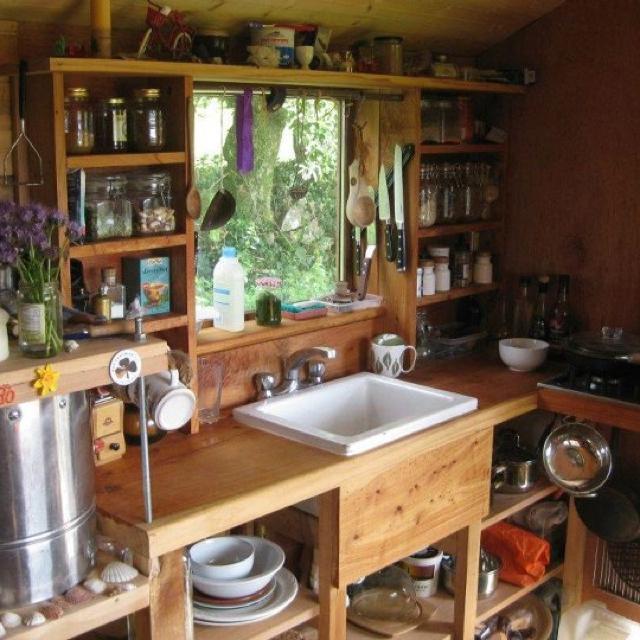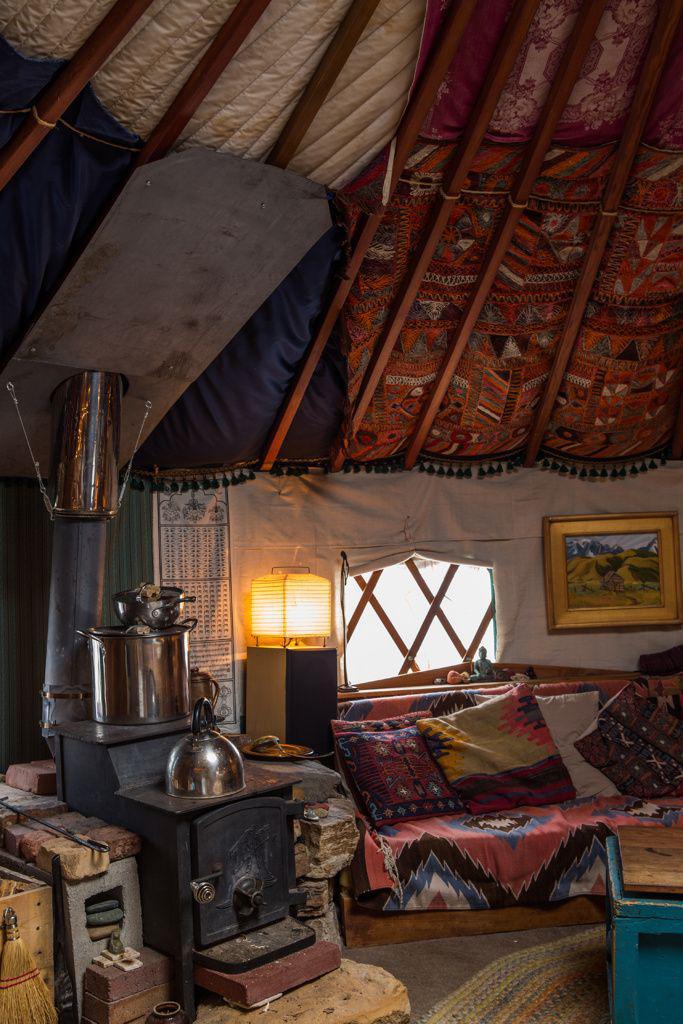The first image is the image on the left, the second image is the image on the right. Evaluate the accuracy of this statement regarding the images: "In one image, a white kitchen sink is built into a wooden cabinet, and is situated in front of a window near wall shelves stocked with kitchen supplies.". Is it true? Answer yes or no. Yes. The first image is the image on the left, the second image is the image on the right. For the images shown, is this caption "An image of a yurt's interior shows a wood slab countertop that ends with a curving corner." true? Answer yes or no. No. 